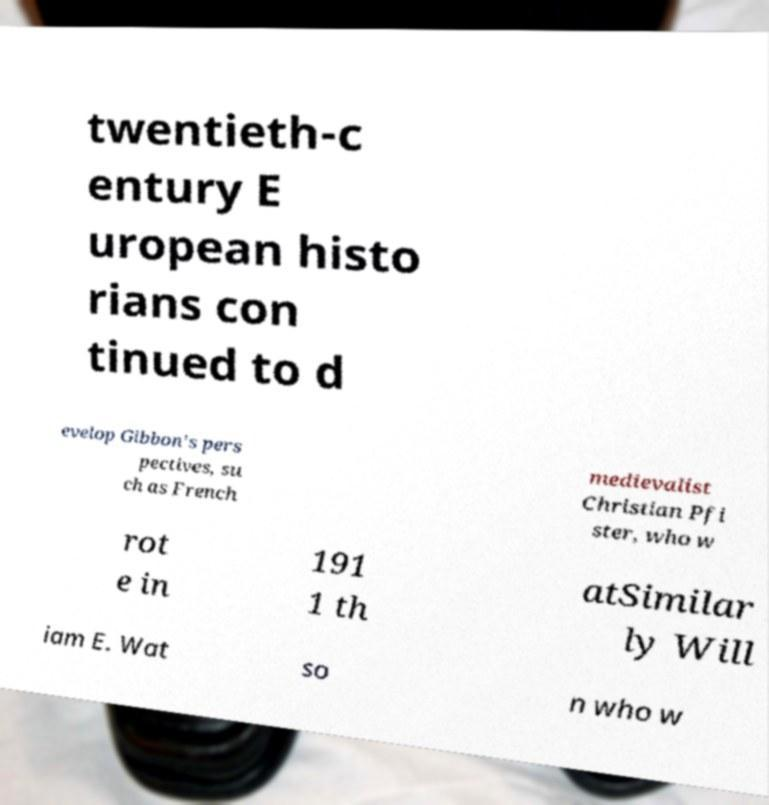Could you assist in decoding the text presented in this image and type it out clearly? twentieth-c entury E uropean histo rians con tinued to d evelop Gibbon's pers pectives, su ch as French medievalist Christian Pfi ster, who w rot e in 191 1 th atSimilar ly Will iam E. Wat so n who w 